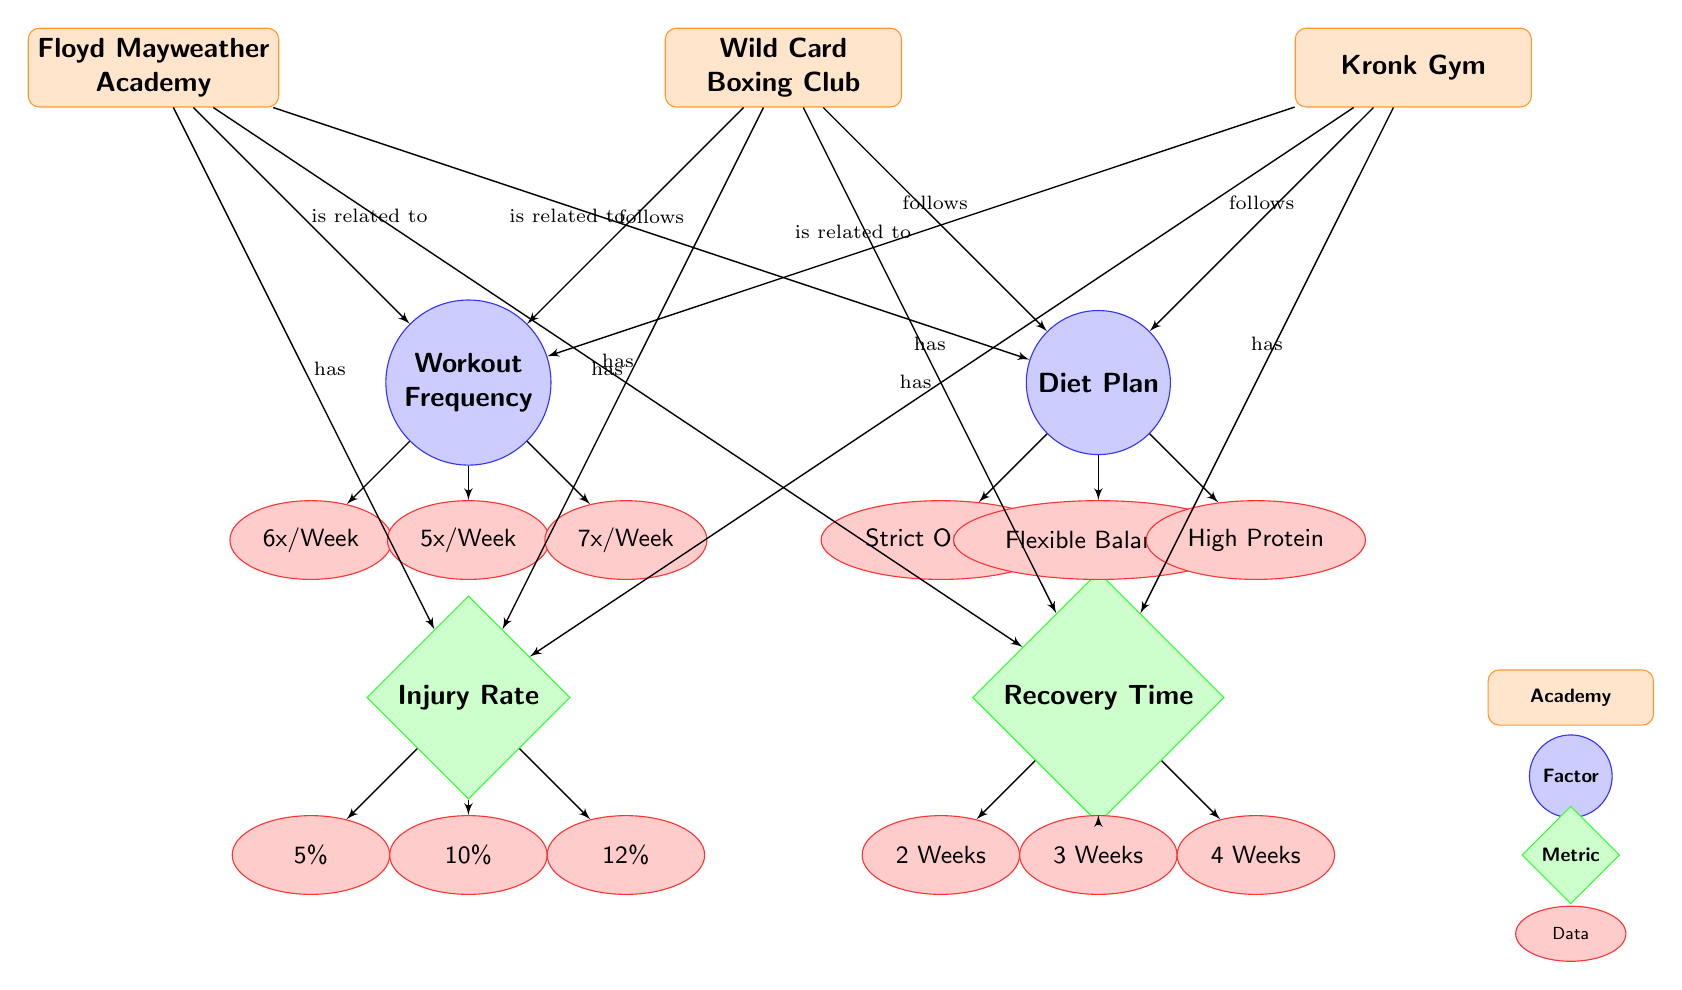What is the workout frequency at the Floyd Mayweather Academy? The diagram indicates that the Floyd Mayweather Academy has a workout frequency of "6x/Week" as shown in the corresponding node connected to the "Workout Frequency" factor.
Answer: 6x/Week What diet plan is followed at the Wild Card Boxing Club? The node for the Wild Card Boxing Club shows that it follows a "Flexible Balanced" diet plan, directly connected to the "Diet Plan" factor.
Answer: Flexible Balanced How many boxing academies are represented in the diagram? The diagram displays three boxing academies: Floyd Mayweather Academy, Wild Card Boxing Club, and Kronk Gym, which can be counted at the top of the diagram.
Answer: 3 Which academy has the highest injury rate? The Kronk Gym has the highest injury rate of "12%" as indicated in its connected data node in the "Injury Rate" section, compared to the 5% and 10% of the other academies.
Answer: 12% What is the recovery time for the Wild Card Boxing Club? The recovery time indicated for the Wild Card Boxing Club is "3 Weeks," as shown in the node connected to the "Recovery Time" metric.
Answer: 3 Weeks Does the Floyd Mayweather Academy have a higher injury rate than the Wild Card Boxing Club? The Floyd Mayweather Academy has an injury rate of "5%" while the Wild Card Boxing Club has "10%," making the Floyd Mayweather Academy's injury rate lower than that of the Wild Card Boxing Club.
Answer: No What is the relationship between workout frequency and the academies? The diagram shows that each academy is related to the "Workout Frequency" factor, confirming that workout frequency is pertinent to all three academies: Floyd Mayweather Academy, Wild Card Boxing Club, and Kronk Gym.
Answer: Related Which diet plan is shared by both the Floyd Mayweather Academy and the Kronk Gym? The Floyd Mayweather Academy and Kronk Gym do not share any diet plan as they follow "Strict Organic" and "High Protein," respectively. This indicates that there is no common diet plan between them.
Answer: None 